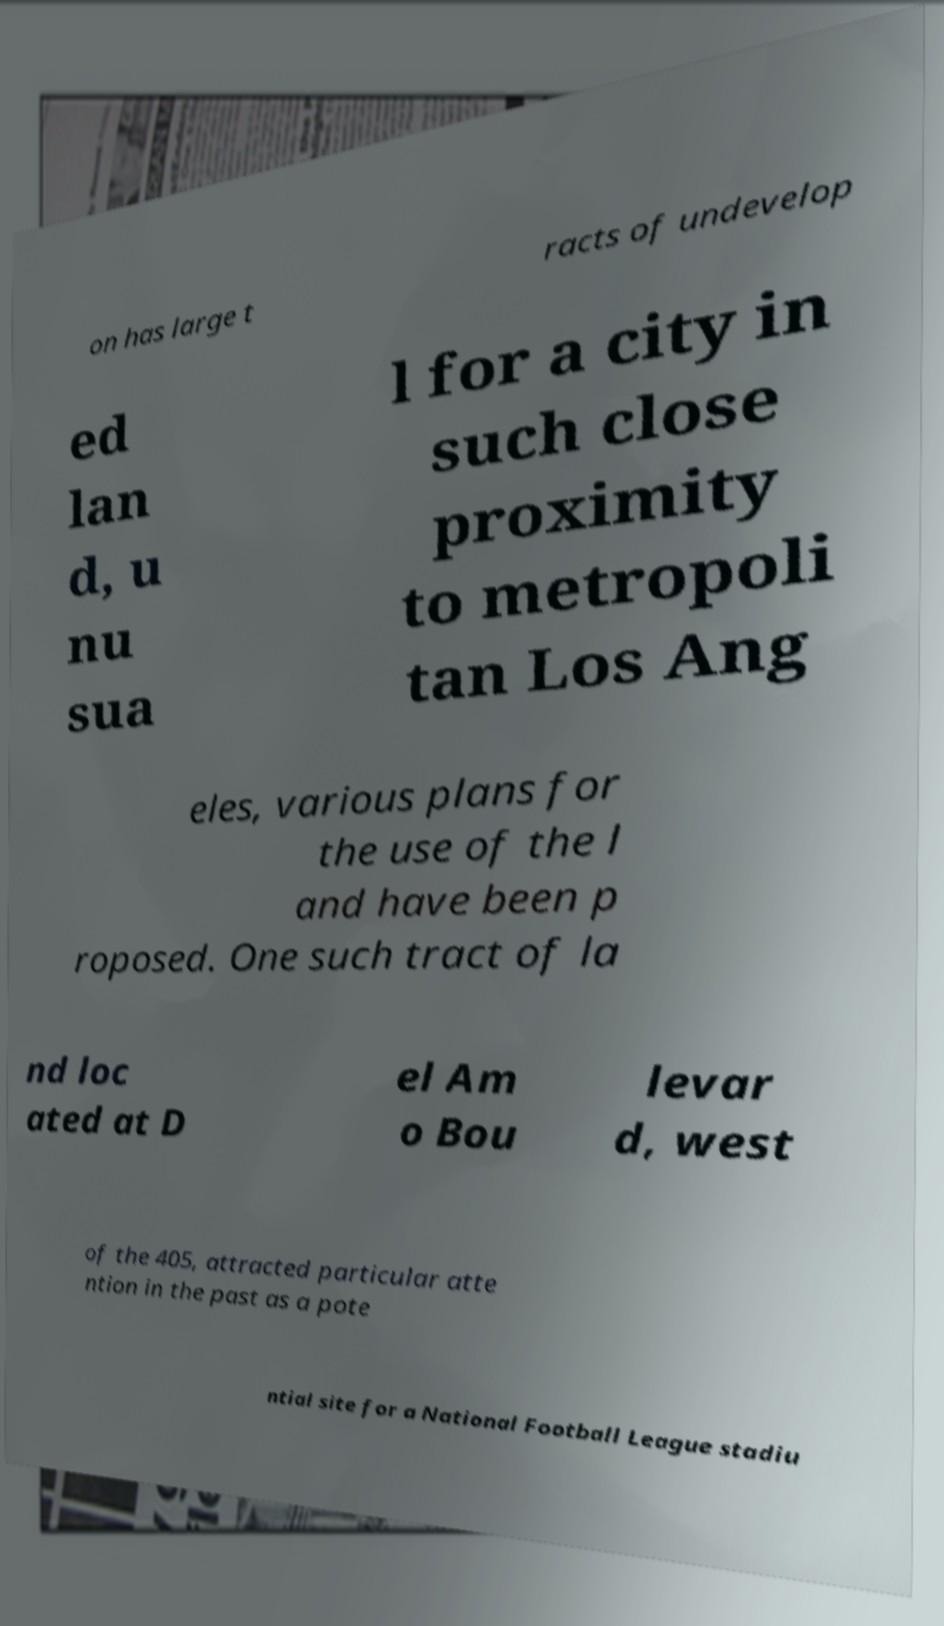There's text embedded in this image that I need extracted. Can you transcribe it verbatim? on has large t racts of undevelop ed lan d, u nu sua l for a city in such close proximity to metropoli tan Los Ang eles, various plans for the use of the l and have been p roposed. One such tract of la nd loc ated at D el Am o Bou levar d, west of the 405, attracted particular atte ntion in the past as a pote ntial site for a National Football League stadiu 